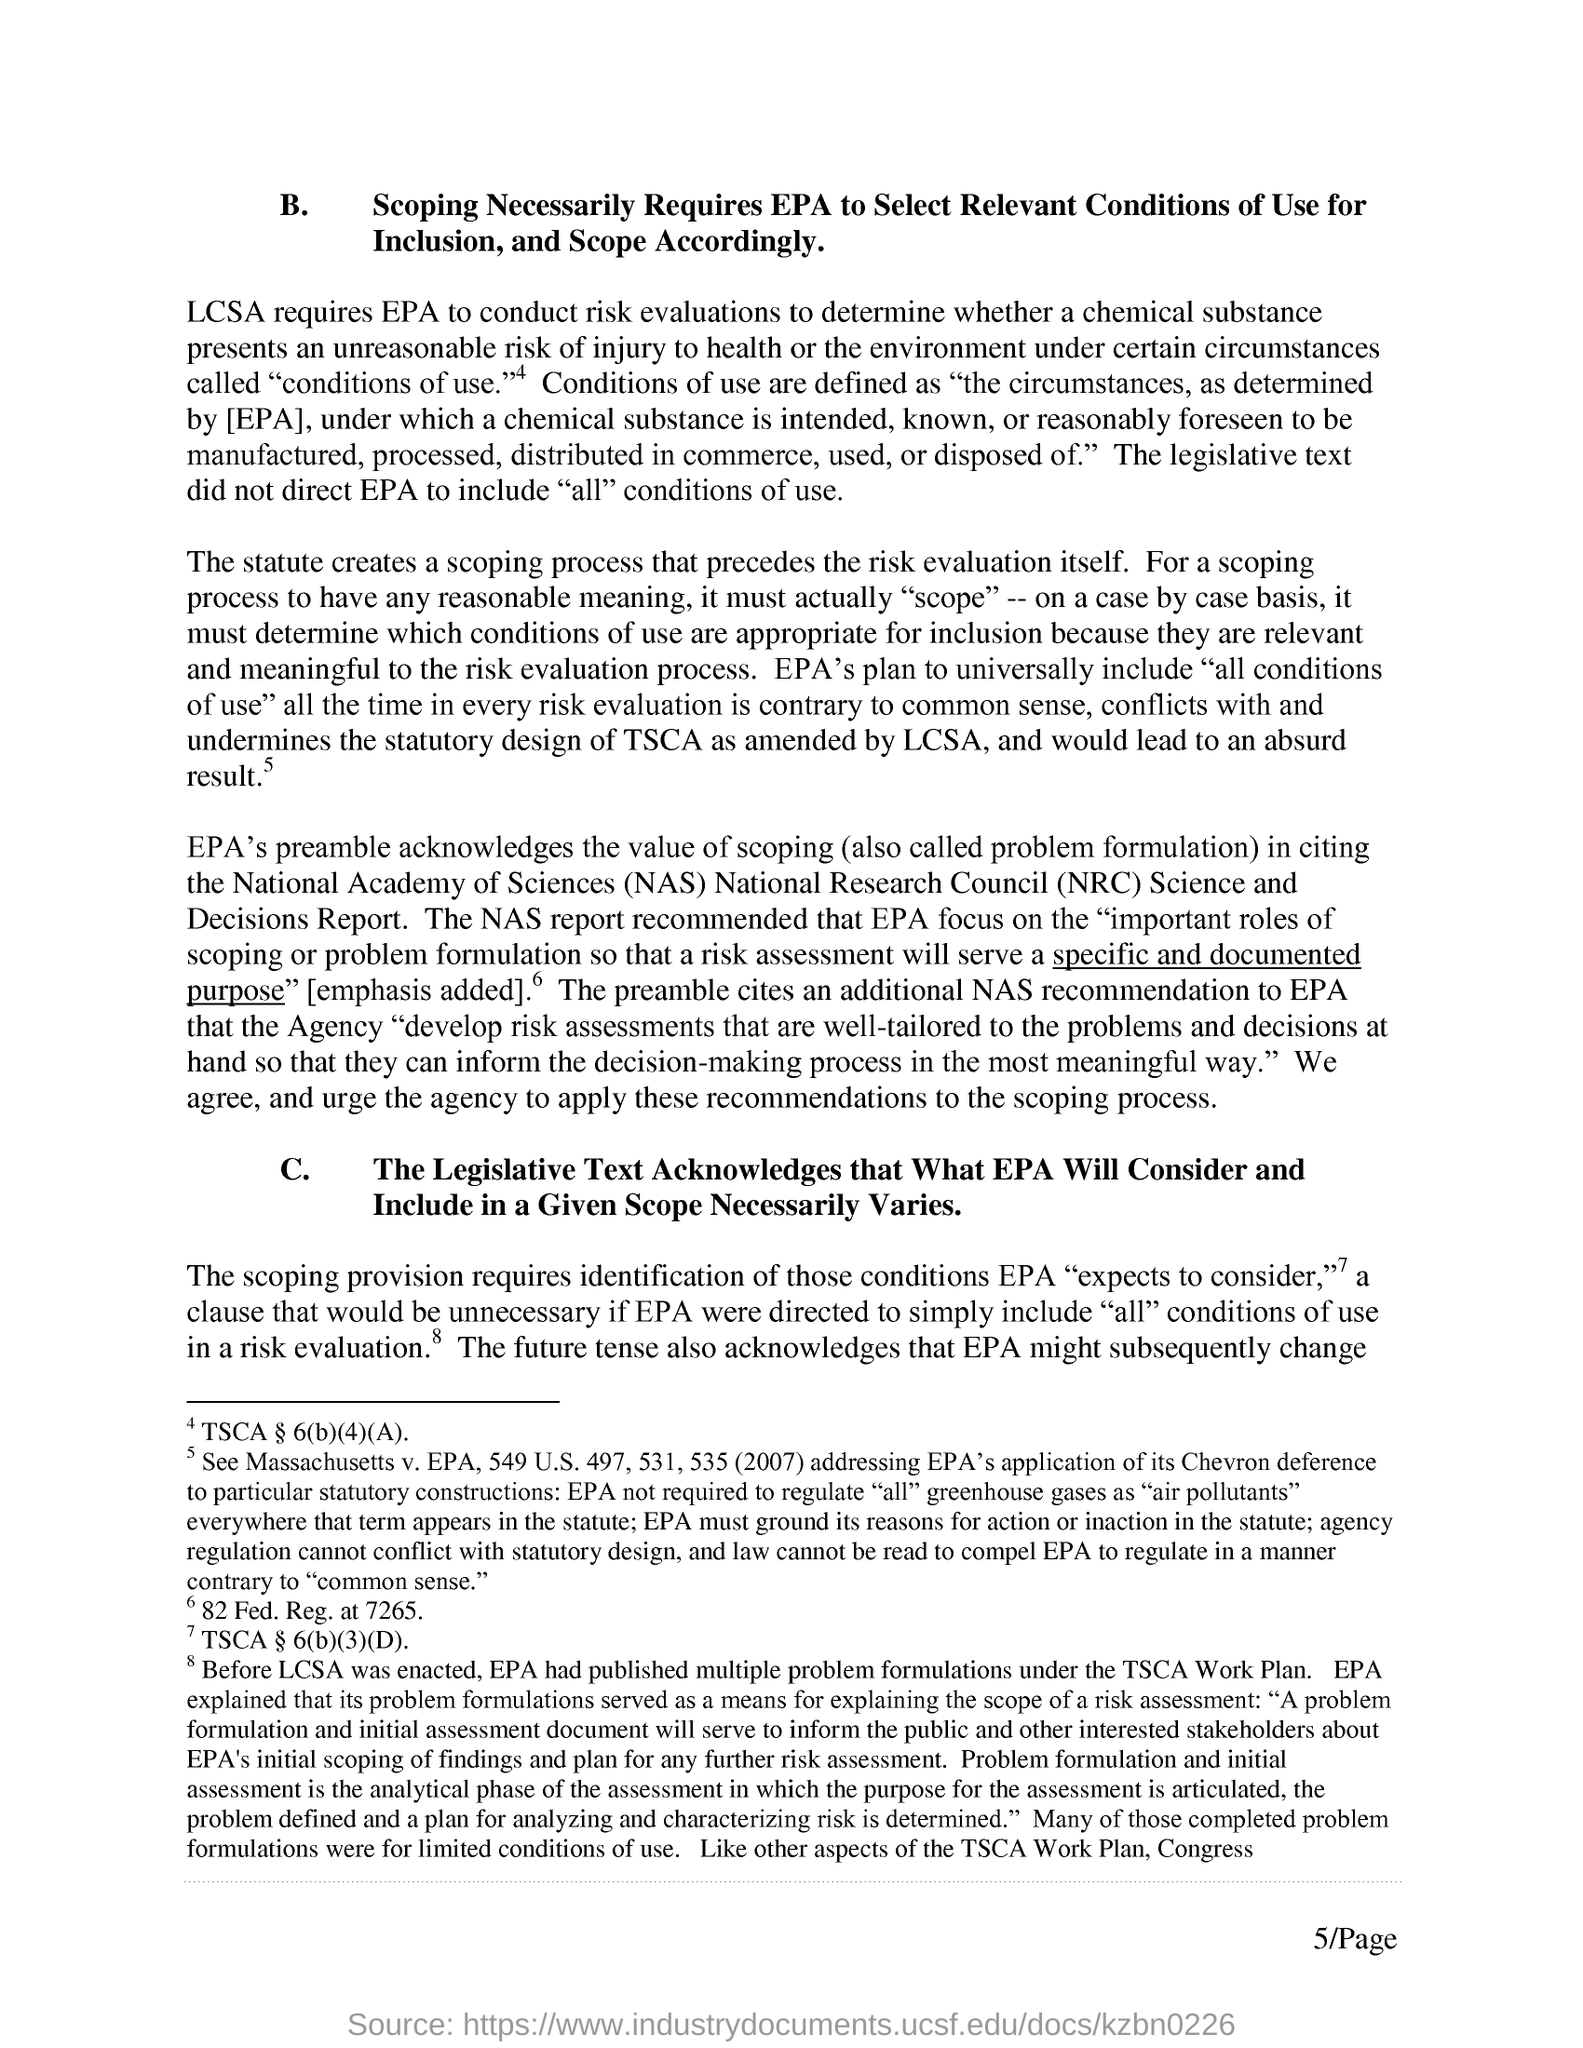LCSA requires what to conduct risk evaluations?
Offer a very short reply. EPA. What is the expansion of "NAS"?
Give a very brief answer. National Academy of Sciences. What is the expansion of "NRC"?
Offer a very short reply. National Research Council. "The NAS report recommended " EPA to focus on what?
Provide a succinct answer. Important roles of scoping or problem formulation so that a risk assessment will serve a specific and documented purpose. What is the first side heading given as "B."?
Provide a short and direct response. Scoping Necessarily Requires EPA to Select Relevant Conditions of use for Inclusion,and Scope Accordingly. What is the second side heading given as "C."?
Your answer should be compact. The legislative text acknowledges that what EPA will consider and include in a given scope necessarily varies. Under what "Work Plan" "EPA had published multiple problem formulations"?
Your response must be concise. TSCA. What is the "Page" number of the document given at the right bottom of the page?
Keep it short and to the point. 5. 